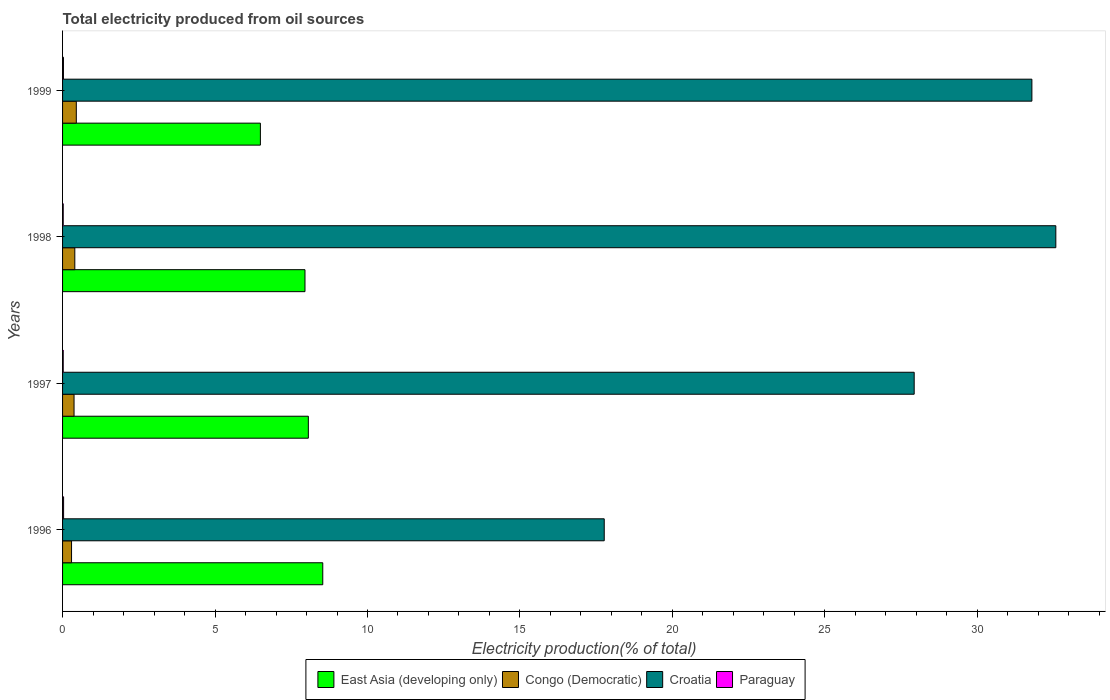How many different coloured bars are there?
Offer a very short reply. 4. Are the number of bars per tick equal to the number of legend labels?
Your response must be concise. Yes. How many bars are there on the 2nd tick from the top?
Keep it short and to the point. 4. How many bars are there on the 1st tick from the bottom?
Provide a succinct answer. 4. What is the label of the 4th group of bars from the top?
Offer a very short reply. 1996. In how many cases, is the number of bars for a given year not equal to the number of legend labels?
Keep it short and to the point. 0. What is the total electricity produced in Congo (Democratic) in 1997?
Offer a terse response. 0.38. Across all years, what is the maximum total electricity produced in Croatia?
Provide a succinct answer. 32.57. Across all years, what is the minimum total electricity produced in Paraguay?
Offer a terse response. 0.02. In which year was the total electricity produced in East Asia (developing only) maximum?
Ensure brevity in your answer.  1996. What is the total total electricity produced in East Asia (developing only) in the graph?
Your response must be concise. 31.03. What is the difference between the total electricity produced in East Asia (developing only) in 1996 and that in 1997?
Your answer should be very brief. 0.47. What is the difference between the total electricity produced in Paraguay in 1996 and the total electricity produced in Congo (Democratic) in 1997?
Offer a very short reply. -0.34. What is the average total electricity produced in Paraguay per year?
Your response must be concise. 0.03. In the year 1997, what is the difference between the total electricity produced in Croatia and total electricity produced in Congo (Democratic)?
Provide a short and direct response. 27.55. What is the ratio of the total electricity produced in Congo (Democratic) in 1997 to that in 1999?
Offer a terse response. 0.84. Is the total electricity produced in Congo (Democratic) in 1997 less than that in 1999?
Provide a short and direct response. Yes. What is the difference between the highest and the second highest total electricity produced in Croatia?
Ensure brevity in your answer.  0.78. What is the difference between the highest and the lowest total electricity produced in Congo (Democratic)?
Make the answer very short. 0.16. Is the sum of the total electricity produced in Croatia in 1996 and 1997 greater than the maximum total electricity produced in East Asia (developing only) across all years?
Your answer should be compact. Yes. Is it the case that in every year, the sum of the total electricity produced in Congo (Democratic) and total electricity produced in Paraguay is greater than the sum of total electricity produced in Croatia and total electricity produced in East Asia (developing only)?
Keep it short and to the point. No. What does the 2nd bar from the top in 1998 represents?
Keep it short and to the point. Croatia. What does the 1st bar from the bottom in 1996 represents?
Offer a terse response. East Asia (developing only). Is it the case that in every year, the sum of the total electricity produced in Congo (Democratic) and total electricity produced in Paraguay is greater than the total electricity produced in Croatia?
Give a very brief answer. No. What is the difference between two consecutive major ticks on the X-axis?
Offer a very short reply. 5. Are the values on the major ticks of X-axis written in scientific E-notation?
Your response must be concise. No. Does the graph contain any zero values?
Provide a succinct answer. No. Does the graph contain grids?
Make the answer very short. No. How many legend labels are there?
Your answer should be very brief. 4. How are the legend labels stacked?
Your response must be concise. Horizontal. What is the title of the graph?
Offer a terse response. Total electricity produced from oil sources. What is the label or title of the Y-axis?
Ensure brevity in your answer.  Years. What is the Electricity production(% of total) of East Asia (developing only) in 1996?
Give a very brief answer. 8.53. What is the Electricity production(% of total) in Congo (Democratic) in 1996?
Your response must be concise. 0.29. What is the Electricity production(% of total) in Croatia in 1996?
Your response must be concise. 17.76. What is the Electricity production(% of total) in Paraguay in 1996?
Your answer should be compact. 0.03. What is the Electricity production(% of total) in East Asia (developing only) in 1997?
Ensure brevity in your answer.  8.06. What is the Electricity production(% of total) in Congo (Democratic) in 1997?
Offer a terse response. 0.38. What is the Electricity production(% of total) in Croatia in 1997?
Offer a terse response. 27.93. What is the Electricity production(% of total) of Paraguay in 1997?
Your answer should be compact. 0.02. What is the Electricity production(% of total) in East Asia (developing only) in 1998?
Your answer should be very brief. 7.95. What is the Electricity production(% of total) of Congo (Democratic) in 1998?
Keep it short and to the point. 0.4. What is the Electricity production(% of total) of Croatia in 1998?
Your answer should be very brief. 32.57. What is the Electricity production(% of total) of Paraguay in 1998?
Your response must be concise. 0.02. What is the Electricity production(% of total) of East Asia (developing only) in 1999?
Keep it short and to the point. 6.49. What is the Electricity production(% of total) of Congo (Democratic) in 1999?
Your answer should be compact. 0.45. What is the Electricity production(% of total) in Croatia in 1999?
Keep it short and to the point. 31.79. What is the Electricity production(% of total) of Paraguay in 1999?
Offer a terse response. 0.03. Across all years, what is the maximum Electricity production(% of total) of East Asia (developing only)?
Ensure brevity in your answer.  8.53. Across all years, what is the maximum Electricity production(% of total) of Congo (Democratic)?
Make the answer very short. 0.45. Across all years, what is the maximum Electricity production(% of total) in Croatia?
Provide a short and direct response. 32.57. Across all years, what is the maximum Electricity production(% of total) in Paraguay?
Offer a very short reply. 0.03. Across all years, what is the minimum Electricity production(% of total) in East Asia (developing only)?
Your answer should be very brief. 6.49. Across all years, what is the minimum Electricity production(% of total) of Congo (Democratic)?
Provide a short and direct response. 0.29. Across all years, what is the minimum Electricity production(% of total) in Croatia?
Your answer should be very brief. 17.76. Across all years, what is the minimum Electricity production(% of total) in Paraguay?
Give a very brief answer. 0.02. What is the total Electricity production(% of total) of East Asia (developing only) in the graph?
Offer a very short reply. 31.03. What is the total Electricity production(% of total) in Congo (Democratic) in the graph?
Provide a succinct answer. 1.52. What is the total Electricity production(% of total) in Croatia in the graph?
Give a very brief answer. 110.06. What is the total Electricity production(% of total) of Paraguay in the graph?
Your answer should be compact. 0.11. What is the difference between the Electricity production(% of total) of East Asia (developing only) in 1996 and that in 1997?
Keep it short and to the point. 0.47. What is the difference between the Electricity production(% of total) of Congo (Democratic) in 1996 and that in 1997?
Ensure brevity in your answer.  -0.08. What is the difference between the Electricity production(% of total) of Croatia in 1996 and that in 1997?
Your response must be concise. -10.16. What is the difference between the Electricity production(% of total) in Paraguay in 1996 and that in 1997?
Ensure brevity in your answer.  0.01. What is the difference between the Electricity production(% of total) of East Asia (developing only) in 1996 and that in 1998?
Give a very brief answer. 0.58. What is the difference between the Electricity production(% of total) in Congo (Democratic) in 1996 and that in 1998?
Make the answer very short. -0.11. What is the difference between the Electricity production(% of total) in Croatia in 1996 and that in 1998?
Provide a short and direct response. -14.81. What is the difference between the Electricity production(% of total) in Paraguay in 1996 and that in 1998?
Your answer should be very brief. 0.01. What is the difference between the Electricity production(% of total) in East Asia (developing only) in 1996 and that in 1999?
Your answer should be compact. 2.05. What is the difference between the Electricity production(% of total) of Congo (Democratic) in 1996 and that in 1999?
Your answer should be very brief. -0.16. What is the difference between the Electricity production(% of total) in Croatia in 1996 and that in 1999?
Provide a succinct answer. -14.02. What is the difference between the Electricity production(% of total) in Paraguay in 1996 and that in 1999?
Your answer should be very brief. 0. What is the difference between the Electricity production(% of total) of East Asia (developing only) in 1997 and that in 1998?
Keep it short and to the point. 0.11. What is the difference between the Electricity production(% of total) in Congo (Democratic) in 1997 and that in 1998?
Provide a succinct answer. -0.03. What is the difference between the Electricity production(% of total) in Croatia in 1997 and that in 1998?
Make the answer very short. -4.65. What is the difference between the Electricity production(% of total) in East Asia (developing only) in 1997 and that in 1999?
Provide a succinct answer. 1.57. What is the difference between the Electricity production(% of total) in Congo (Democratic) in 1997 and that in 1999?
Provide a short and direct response. -0.07. What is the difference between the Electricity production(% of total) of Croatia in 1997 and that in 1999?
Offer a very short reply. -3.86. What is the difference between the Electricity production(% of total) of Paraguay in 1997 and that in 1999?
Keep it short and to the point. -0.01. What is the difference between the Electricity production(% of total) in East Asia (developing only) in 1998 and that in 1999?
Provide a succinct answer. 1.46. What is the difference between the Electricity production(% of total) in Congo (Democratic) in 1998 and that in 1999?
Offer a very short reply. -0.05. What is the difference between the Electricity production(% of total) of Croatia in 1998 and that in 1999?
Provide a succinct answer. 0.78. What is the difference between the Electricity production(% of total) in Paraguay in 1998 and that in 1999?
Your answer should be very brief. -0.01. What is the difference between the Electricity production(% of total) of East Asia (developing only) in 1996 and the Electricity production(% of total) of Congo (Democratic) in 1997?
Offer a very short reply. 8.16. What is the difference between the Electricity production(% of total) of East Asia (developing only) in 1996 and the Electricity production(% of total) of Croatia in 1997?
Offer a very short reply. -19.4. What is the difference between the Electricity production(% of total) in East Asia (developing only) in 1996 and the Electricity production(% of total) in Paraguay in 1997?
Give a very brief answer. 8.51. What is the difference between the Electricity production(% of total) in Congo (Democratic) in 1996 and the Electricity production(% of total) in Croatia in 1997?
Provide a short and direct response. -27.63. What is the difference between the Electricity production(% of total) in Congo (Democratic) in 1996 and the Electricity production(% of total) in Paraguay in 1997?
Offer a terse response. 0.27. What is the difference between the Electricity production(% of total) of Croatia in 1996 and the Electricity production(% of total) of Paraguay in 1997?
Give a very brief answer. 17.74. What is the difference between the Electricity production(% of total) in East Asia (developing only) in 1996 and the Electricity production(% of total) in Congo (Democratic) in 1998?
Offer a terse response. 8.13. What is the difference between the Electricity production(% of total) of East Asia (developing only) in 1996 and the Electricity production(% of total) of Croatia in 1998?
Give a very brief answer. -24.04. What is the difference between the Electricity production(% of total) of East Asia (developing only) in 1996 and the Electricity production(% of total) of Paraguay in 1998?
Offer a terse response. 8.51. What is the difference between the Electricity production(% of total) of Congo (Democratic) in 1996 and the Electricity production(% of total) of Croatia in 1998?
Ensure brevity in your answer.  -32.28. What is the difference between the Electricity production(% of total) of Congo (Democratic) in 1996 and the Electricity production(% of total) of Paraguay in 1998?
Your answer should be compact. 0.27. What is the difference between the Electricity production(% of total) of Croatia in 1996 and the Electricity production(% of total) of Paraguay in 1998?
Your answer should be compact. 17.74. What is the difference between the Electricity production(% of total) of East Asia (developing only) in 1996 and the Electricity production(% of total) of Congo (Democratic) in 1999?
Your answer should be very brief. 8.08. What is the difference between the Electricity production(% of total) in East Asia (developing only) in 1996 and the Electricity production(% of total) in Croatia in 1999?
Provide a succinct answer. -23.26. What is the difference between the Electricity production(% of total) of East Asia (developing only) in 1996 and the Electricity production(% of total) of Paraguay in 1999?
Your answer should be compact. 8.5. What is the difference between the Electricity production(% of total) of Congo (Democratic) in 1996 and the Electricity production(% of total) of Croatia in 1999?
Your answer should be compact. -31.49. What is the difference between the Electricity production(% of total) in Congo (Democratic) in 1996 and the Electricity production(% of total) in Paraguay in 1999?
Your answer should be compact. 0.27. What is the difference between the Electricity production(% of total) in Croatia in 1996 and the Electricity production(% of total) in Paraguay in 1999?
Give a very brief answer. 17.74. What is the difference between the Electricity production(% of total) of East Asia (developing only) in 1997 and the Electricity production(% of total) of Congo (Democratic) in 1998?
Ensure brevity in your answer.  7.66. What is the difference between the Electricity production(% of total) of East Asia (developing only) in 1997 and the Electricity production(% of total) of Croatia in 1998?
Offer a terse response. -24.51. What is the difference between the Electricity production(% of total) of East Asia (developing only) in 1997 and the Electricity production(% of total) of Paraguay in 1998?
Give a very brief answer. 8.04. What is the difference between the Electricity production(% of total) in Congo (Democratic) in 1997 and the Electricity production(% of total) in Croatia in 1998?
Offer a very short reply. -32.2. What is the difference between the Electricity production(% of total) in Congo (Democratic) in 1997 and the Electricity production(% of total) in Paraguay in 1998?
Your answer should be compact. 0.36. What is the difference between the Electricity production(% of total) of Croatia in 1997 and the Electricity production(% of total) of Paraguay in 1998?
Offer a terse response. 27.91. What is the difference between the Electricity production(% of total) of East Asia (developing only) in 1997 and the Electricity production(% of total) of Congo (Democratic) in 1999?
Ensure brevity in your answer.  7.61. What is the difference between the Electricity production(% of total) of East Asia (developing only) in 1997 and the Electricity production(% of total) of Croatia in 1999?
Your answer should be very brief. -23.73. What is the difference between the Electricity production(% of total) in East Asia (developing only) in 1997 and the Electricity production(% of total) in Paraguay in 1999?
Provide a succinct answer. 8.03. What is the difference between the Electricity production(% of total) of Congo (Democratic) in 1997 and the Electricity production(% of total) of Croatia in 1999?
Your response must be concise. -31.41. What is the difference between the Electricity production(% of total) in Congo (Democratic) in 1997 and the Electricity production(% of total) in Paraguay in 1999?
Ensure brevity in your answer.  0.35. What is the difference between the Electricity production(% of total) of Croatia in 1997 and the Electricity production(% of total) of Paraguay in 1999?
Offer a terse response. 27.9. What is the difference between the Electricity production(% of total) of East Asia (developing only) in 1998 and the Electricity production(% of total) of Congo (Democratic) in 1999?
Your answer should be compact. 7.5. What is the difference between the Electricity production(% of total) of East Asia (developing only) in 1998 and the Electricity production(% of total) of Croatia in 1999?
Offer a very short reply. -23.84. What is the difference between the Electricity production(% of total) in East Asia (developing only) in 1998 and the Electricity production(% of total) in Paraguay in 1999?
Provide a succinct answer. 7.92. What is the difference between the Electricity production(% of total) in Congo (Democratic) in 1998 and the Electricity production(% of total) in Croatia in 1999?
Your answer should be very brief. -31.39. What is the difference between the Electricity production(% of total) of Congo (Democratic) in 1998 and the Electricity production(% of total) of Paraguay in 1999?
Your answer should be compact. 0.37. What is the difference between the Electricity production(% of total) in Croatia in 1998 and the Electricity production(% of total) in Paraguay in 1999?
Provide a succinct answer. 32.55. What is the average Electricity production(% of total) of East Asia (developing only) per year?
Provide a succinct answer. 7.76. What is the average Electricity production(% of total) of Congo (Democratic) per year?
Ensure brevity in your answer.  0.38. What is the average Electricity production(% of total) in Croatia per year?
Offer a terse response. 27.51. What is the average Electricity production(% of total) of Paraguay per year?
Provide a short and direct response. 0.03. In the year 1996, what is the difference between the Electricity production(% of total) in East Asia (developing only) and Electricity production(% of total) in Congo (Democratic)?
Keep it short and to the point. 8.24. In the year 1996, what is the difference between the Electricity production(% of total) of East Asia (developing only) and Electricity production(% of total) of Croatia?
Keep it short and to the point. -9.23. In the year 1996, what is the difference between the Electricity production(% of total) in East Asia (developing only) and Electricity production(% of total) in Paraguay?
Give a very brief answer. 8.5. In the year 1996, what is the difference between the Electricity production(% of total) in Congo (Democratic) and Electricity production(% of total) in Croatia?
Your response must be concise. -17.47. In the year 1996, what is the difference between the Electricity production(% of total) in Congo (Democratic) and Electricity production(% of total) in Paraguay?
Provide a succinct answer. 0.26. In the year 1996, what is the difference between the Electricity production(% of total) of Croatia and Electricity production(% of total) of Paraguay?
Ensure brevity in your answer.  17.73. In the year 1997, what is the difference between the Electricity production(% of total) in East Asia (developing only) and Electricity production(% of total) in Congo (Democratic)?
Give a very brief answer. 7.68. In the year 1997, what is the difference between the Electricity production(% of total) in East Asia (developing only) and Electricity production(% of total) in Croatia?
Give a very brief answer. -19.87. In the year 1997, what is the difference between the Electricity production(% of total) in East Asia (developing only) and Electricity production(% of total) in Paraguay?
Keep it short and to the point. 8.04. In the year 1997, what is the difference between the Electricity production(% of total) of Congo (Democratic) and Electricity production(% of total) of Croatia?
Your response must be concise. -27.55. In the year 1997, what is the difference between the Electricity production(% of total) of Congo (Democratic) and Electricity production(% of total) of Paraguay?
Ensure brevity in your answer.  0.36. In the year 1997, what is the difference between the Electricity production(% of total) in Croatia and Electricity production(% of total) in Paraguay?
Offer a terse response. 27.91. In the year 1998, what is the difference between the Electricity production(% of total) of East Asia (developing only) and Electricity production(% of total) of Congo (Democratic)?
Provide a short and direct response. 7.55. In the year 1998, what is the difference between the Electricity production(% of total) in East Asia (developing only) and Electricity production(% of total) in Croatia?
Your answer should be very brief. -24.62. In the year 1998, what is the difference between the Electricity production(% of total) in East Asia (developing only) and Electricity production(% of total) in Paraguay?
Your answer should be compact. 7.93. In the year 1998, what is the difference between the Electricity production(% of total) of Congo (Democratic) and Electricity production(% of total) of Croatia?
Ensure brevity in your answer.  -32.17. In the year 1998, what is the difference between the Electricity production(% of total) in Congo (Democratic) and Electricity production(% of total) in Paraguay?
Your answer should be compact. 0.38. In the year 1998, what is the difference between the Electricity production(% of total) of Croatia and Electricity production(% of total) of Paraguay?
Make the answer very short. 32.55. In the year 1999, what is the difference between the Electricity production(% of total) of East Asia (developing only) and Electricity production(% of total) of Congo (Democratic)?
Your answer should be very brief. 6.04. In the year 1999, what is the difference between the Electricity production(% of total) of East Asia (developing only) and Electricity production(% of total) of Croatia?
Give a very brief answer. -25.3. In the year 1999, what is the difference between the Electricity production(% of total) of East Asia (developing only) and Electricity production(% of total) of Paraguay?
Offer a very short reply. 6.46. In the year 1999, what is the difference between the Electricity production(% of total) in Congo (Democratic) and Electricity production(% of total) in Croatia?
Your answer should be very brief. -31.34. In the year 1999, what is the difference between the Electricity production(% of total) of Congo (Democratic) and Electricity production(% of total) of Paraguay?
Your answer should be very brief. 0.42. In the year 1999, what is the difference between the Electricity production(% of total) of Croatia and Electricity production(% of total) of Paraguay?
Your response must be concise. 31.76. What is the ratio of the Electricity production(% of total) of East Asia (developing only) in 1996 to that in 1997?
Your answer should be compact. 1.06. What is the ratio of the Electricity production(% of total) of Congo (Democratic) in 1996 to that in 1997?
Keep it short and to the point. 0.78. What is the ratio of the Electricity production(% of total) in Croatia in 1996 to that in 1997?
Give a very brief answer. 0.64. What is the ratio of the Electricity production(% of total) in Paraguay in 1996 to that in 1997?
Give a very brief answer. 1.55. What is the ratio of the Electricity production(% of total) in East Asia (developing only) in 1996 to that in 1998?
Your response must be concise. 1.07. What is the ratio of the Electricity production(% of total) of Congo (Democratic) in 1996 to that in 1998?
Offer a very short reply. 0.73. What is the ratio of the Electricity production(% of total) of Croatia in 1996 to that in 1998?
Your answer should be compact. 0.55. What is the ratio of the Electricity production(% of total) of Paraguay in 1996 to that in 1998?
Your response must be concise. 1.55. What is the ratio of the Electricity production(% of total) of East Asia (developing only) in 1996 to that in 1999?
Offer a very short reply. 1.32. What is the ratio of the Electricity production(% of total) in Congo (Democratic) in 1996 to that in 1999?
Give a very brief answer. 0.65. What is the ratio of the Electricity production(% of total) in Croatia in 1996 to that in 1999?
Ensure brevity in your answer.  0.56. What is the ratio of the Electricity production(% of total) in Paraguay in 1996 to that in 1999?
Offer a very short reply. 1.16. What is the ratio of the Electricity production(% of total) of East Asia (developing only) in 1997 to that in 1998?
Offer a very short reply. 1.01. What is the ratio of the Electricity production(% of total) of Croatia in 1997 to that in 1998?
Provide a succinct answer. 0.86. What is the ratio of the Electricity production(% of total) of Paraguay in 1997 to that in 1998?
Your answer should be very brief. 1. What is the ratio of the Electricity production(% of total) in East Asia (developing only) in 1997 to that in 1999?
Keep it short and to the point. 1.24. What is the ratio of the Electricity production(% of total) in Congo (Democratic) in 1997 to that in 1999?
Offer a terse response. 0.84. What is the ratio of the Electricity production(% of total) of Croatia in 1997 to that in 1999?
Offer a very short reply. 0.88. What is the ratio of the Electricity production(% of total) of Paraguay in 1997 to that in 1999?
Your answer should be compact. 0.75. What is the ratio of the Electricity production(% of total) of East Asia (developing only) in 1998 to that in 1999?
Offer a terse response. 1.23. What is the ratio of the Electricity production(% of total) of Congo (Democratic) in 1998 to that in 1999?
Your response must be concise. 0.89. What is the ratio of the Electricity production(% of total) in Croatia in 1998 to that in 1999?
Keep it short and to the point. 1.02. What is the ratio of the Electricity production(% of total) in Paraguay in 1998 to that in 1999?
Offer a very short reply. 0.75. What is the difference between the highest and the second highest Electricity production(% of total) of East Asia (developing only)?
Offer a very short reply. 0.47. What is the difference between the highest and the second highest Electricity production(% of total) in Congo (Democratic)?
Ensure brevity in your answer.  0.05. What is the difference between the highest and the second highest Electricity production(% of total) of Croatia?
Your answer should be very brief. 0.78. What is the difference between the highest and the second highest Electricity production(% of total) in Paraguay?
Your answer should be very brief. 0. What is the difference between the highest and the lowest Electricity production(% of total) in East Asia (developing only)?
Ensure brevity in your answer.  2.05. What is the difference between the highest and the lowest Electricity production(% of total) in Congo (Democratic)?
Your response must be concise. 0.16. What is the difference between the highest and the lowest Electricity production(% of total) of Croatia?
Provide a succinct answer. 14.81. What is the difference between the highest and the lowest Electricity production(% of total) of Paraguay?
Offer a very short reply. 0.01. 